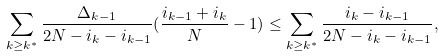<formula> <loc_0><loc_0><loc_500><loc_500>\sum _ { k \geq k ^ { * } } \frac { \Delta _ { k - 1 } } { 2 N - i _ { k } - i _ { k - 1 } } ( \frac { i _ { k - 1 } + i _ { k } } { N } - 1 ) \leq \sum _ { k \geq k ^ { * } } \frac { i _ { k } - i _ { k - 1 } } { 2 N - i _ { k } - i _ { k - 1 } } ,</formula> 